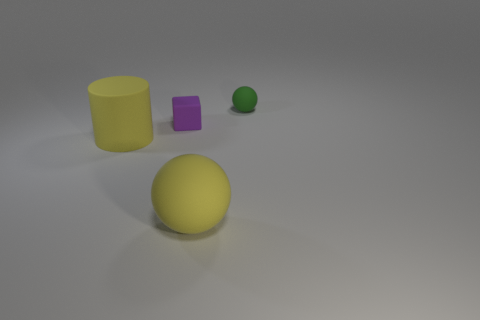Add 2 large things. How many objects exist? 6 Subtract all blocks. How many objects are left? 3 Subtract all small purple rubber things. Subtract all yellow rubber cylinders. How many objects are left? 2 Add 2 balls. How many balls are left? 4 Add 2 large yellow things. How many large yellow things exist? 4 Subtract 0 gray cylinders. How many objects are left? 4 